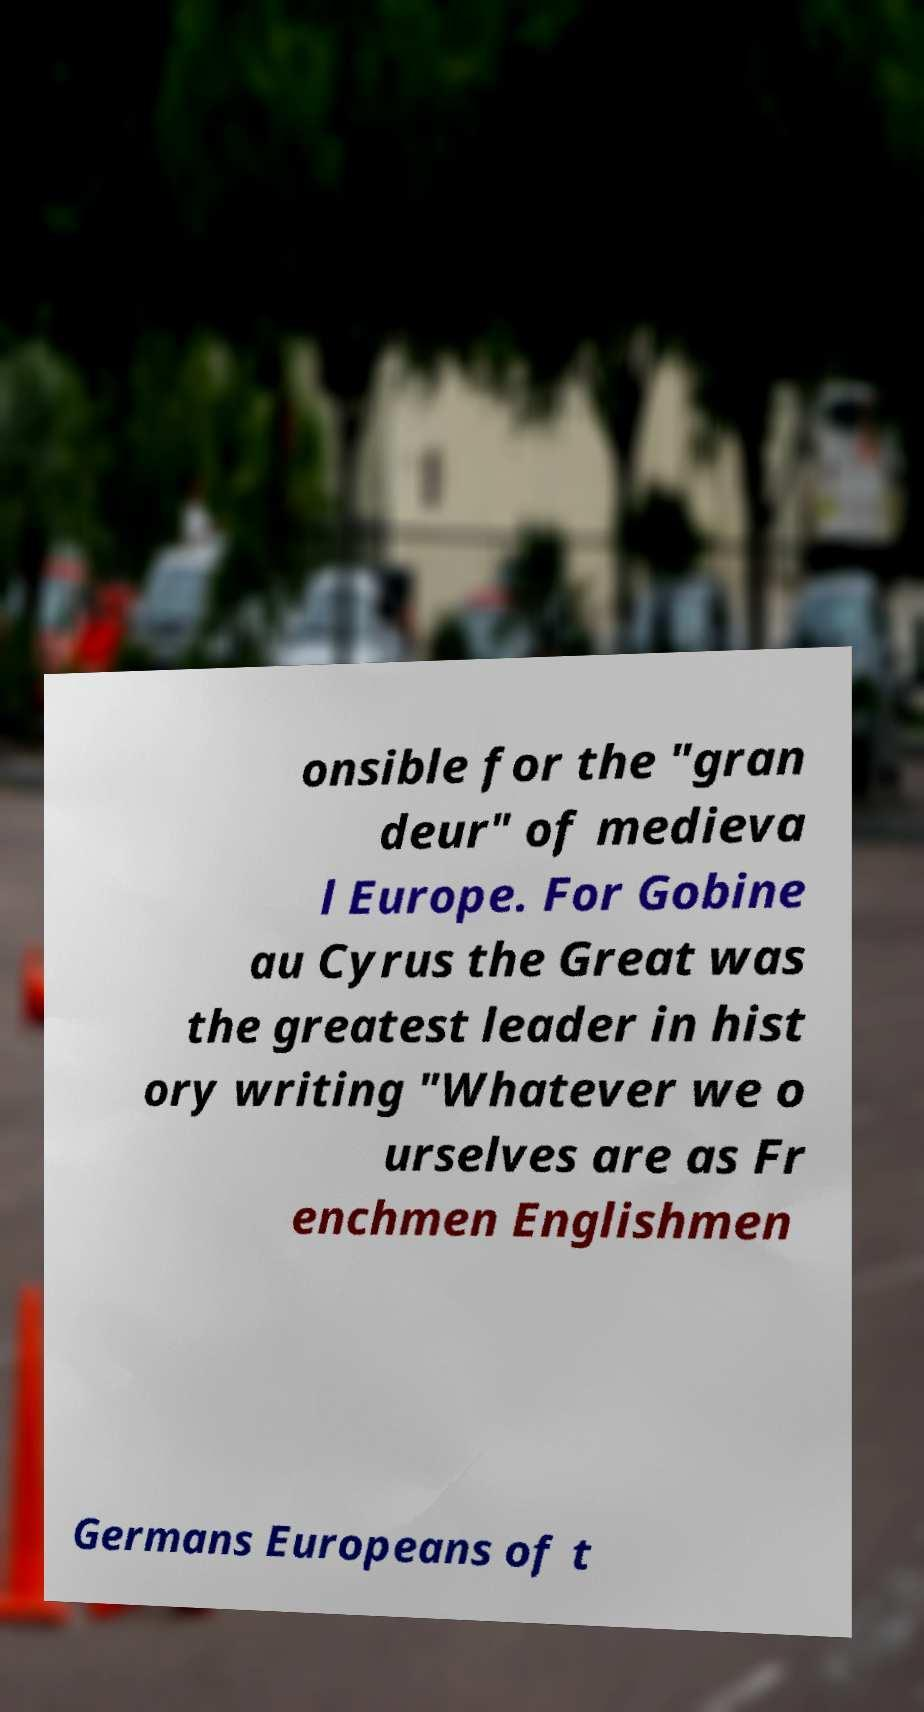Can you accurately transcribe the text from the provided image for me? onsible for the "gran deur" of medieva l Europe. For Gobine au Cyrus the Great was the greatest leader in hist ory writing "Whatever we o urselves are as Fr enchmen Englishmen Germans Europeans of t 